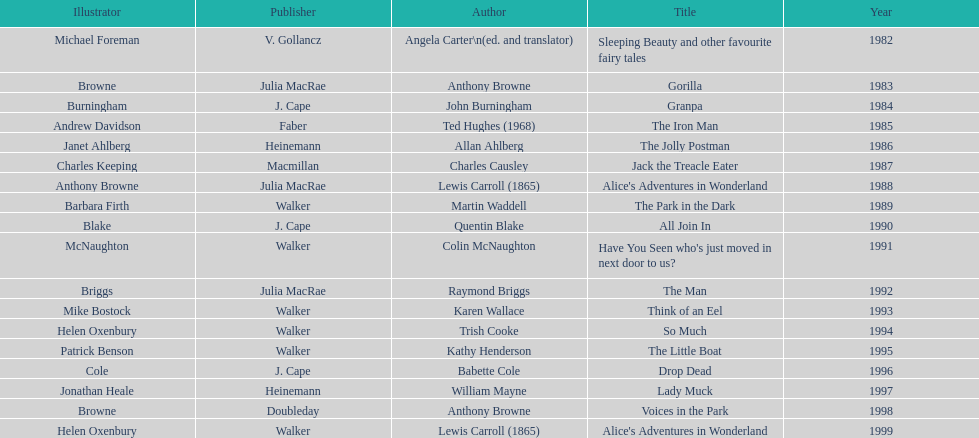What's the difference in years between angela carter's title and anthony browne's? 1. 